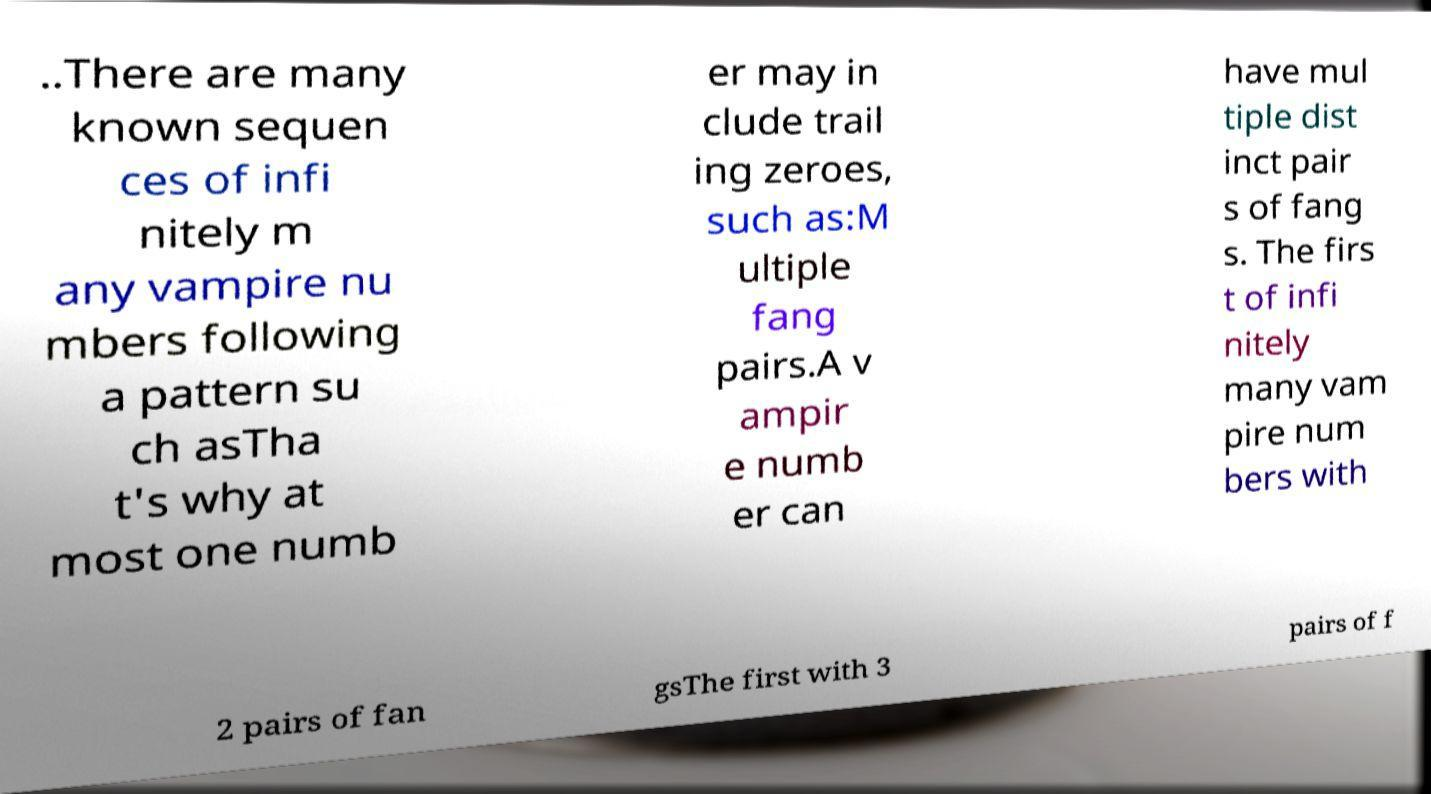Could you extract and type out the text from this image? ..There are many known sequen ces of infi nitely m any vampire nu mbers following a pattern su ch asTha t's why at most one numb er may in clude trail ing zeroes, such as:M ultiple fang pairs.A v ampir e numb er can have mul tiple dist inct pair s of fang s. The firs t of infi nitely many vam pire num bers with 2 pairs of fan gsThe first with 3 pairs of f 